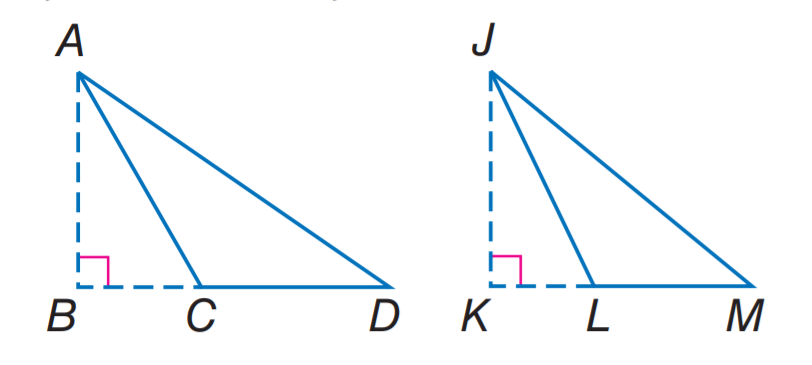Question: If A B and J K are altitudes, \triangle D A C \sim \triangle M J L, A B = 9, A D = 4 x - 8, J K = 21, and J M = 5 x + 3, find x.
Choices:
A. 4
B. 5
C. 8
D. 9
Answer with the letter. Answer: B 